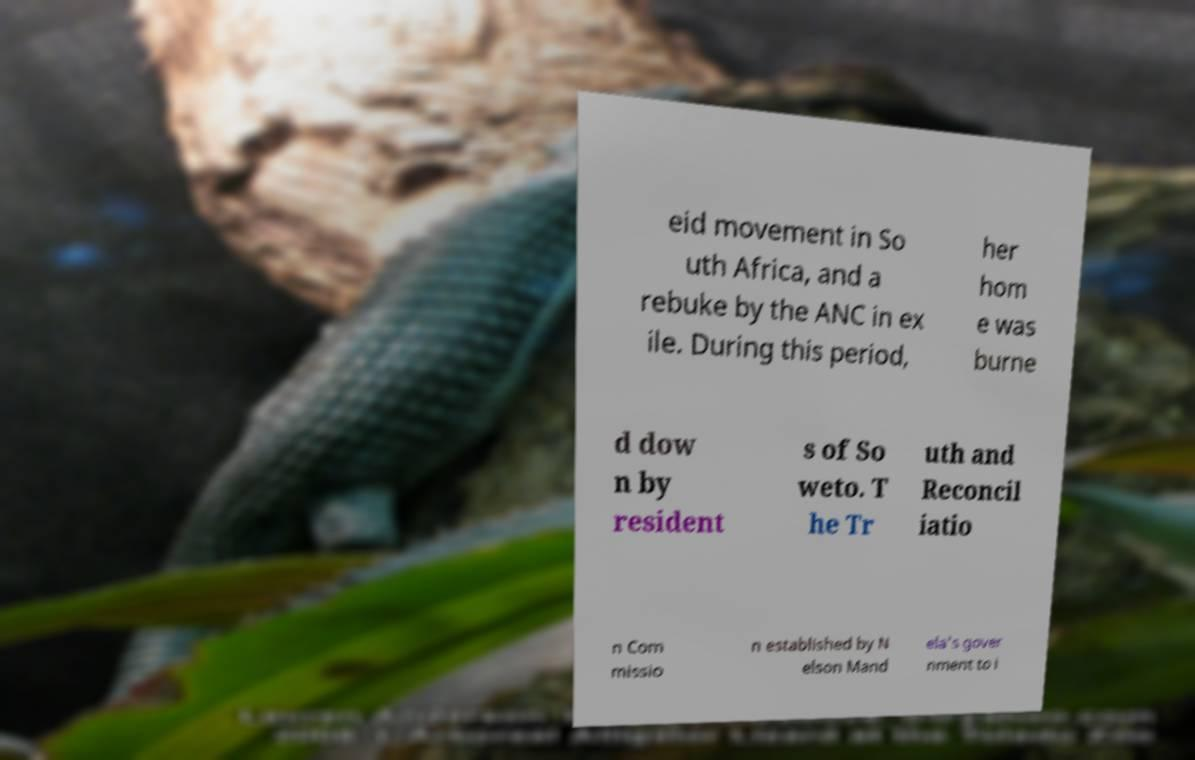There's text embedded in this image that I need extracted. Can you transcribe it verbatim? eid movement in So uth Africa, and a rebuke by the ANC in ex ile. During this period, her hom e was burne d dow n by resident s of So weto. T he Tr uth and Reconcil iatio n Com missio n established by N elson Mand ela's gover nment to i 